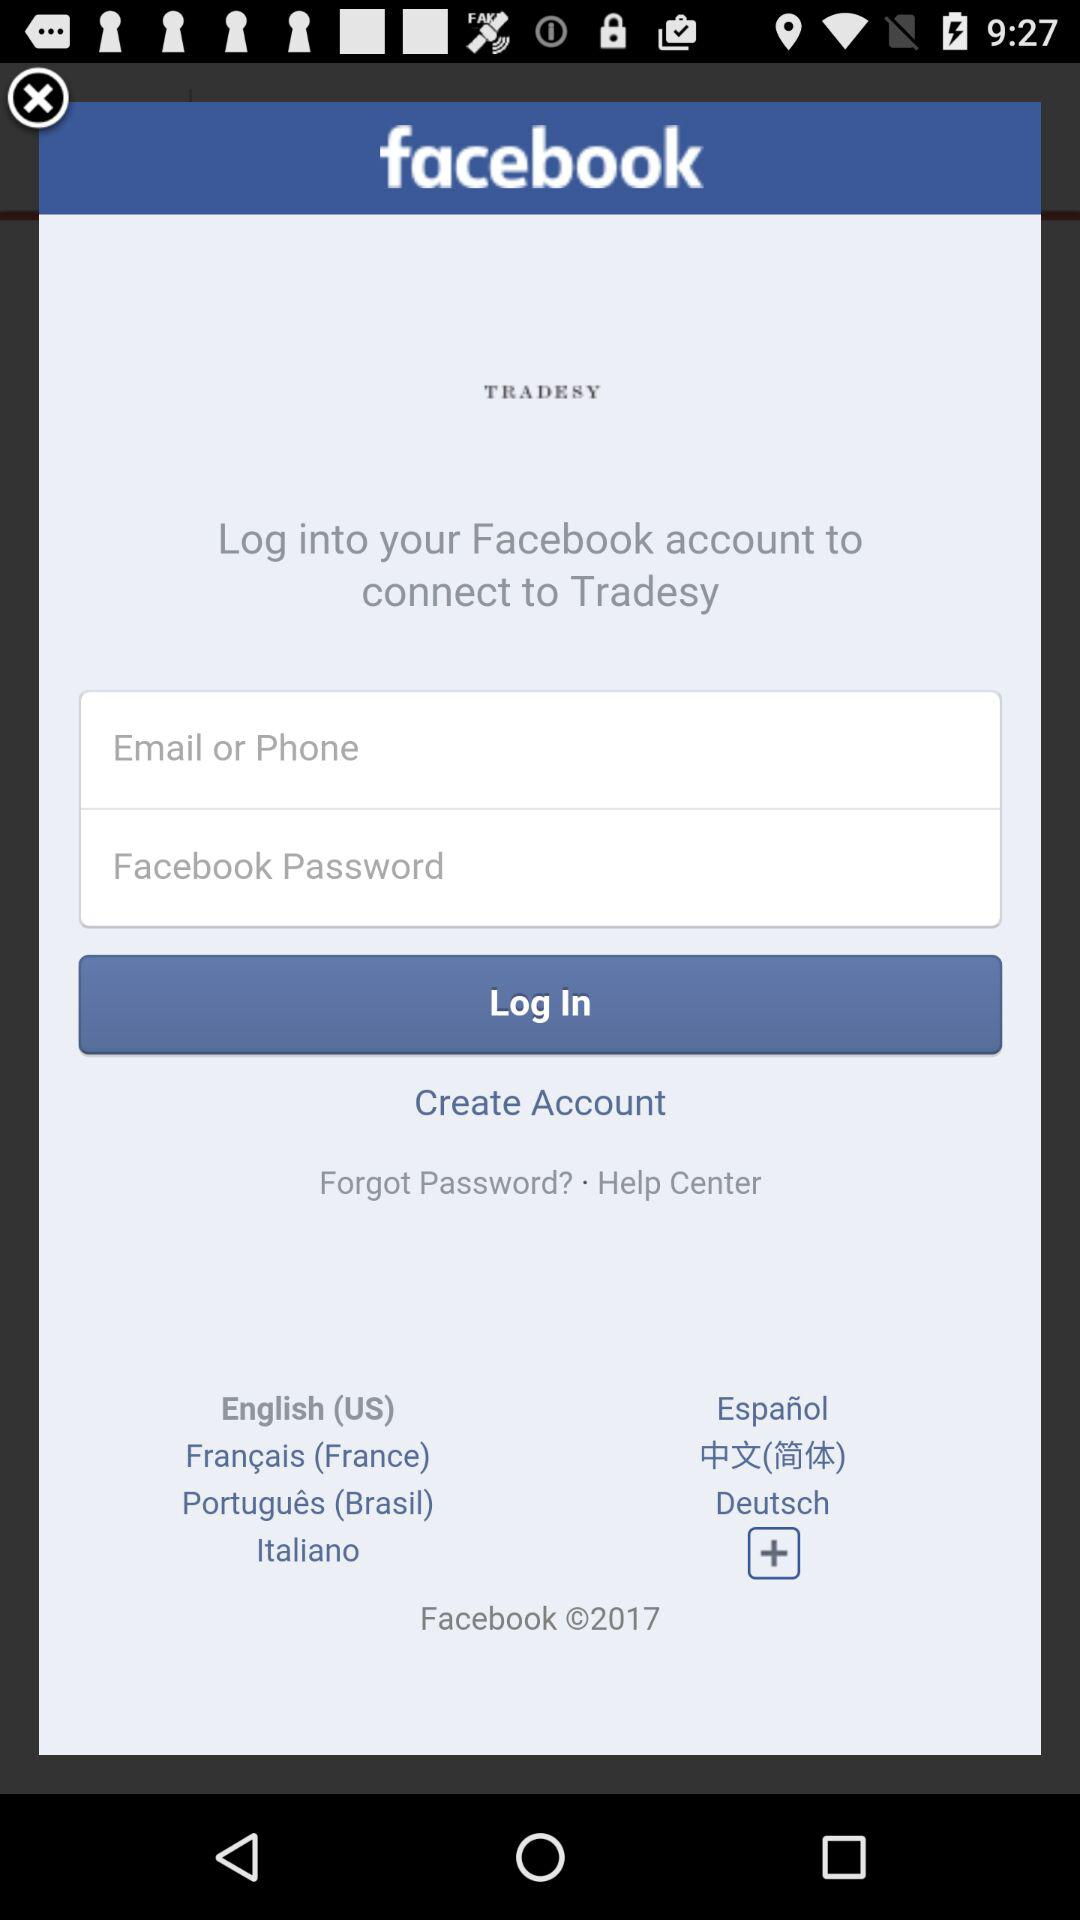What is the name of the application? The name of the application is "facebook". 